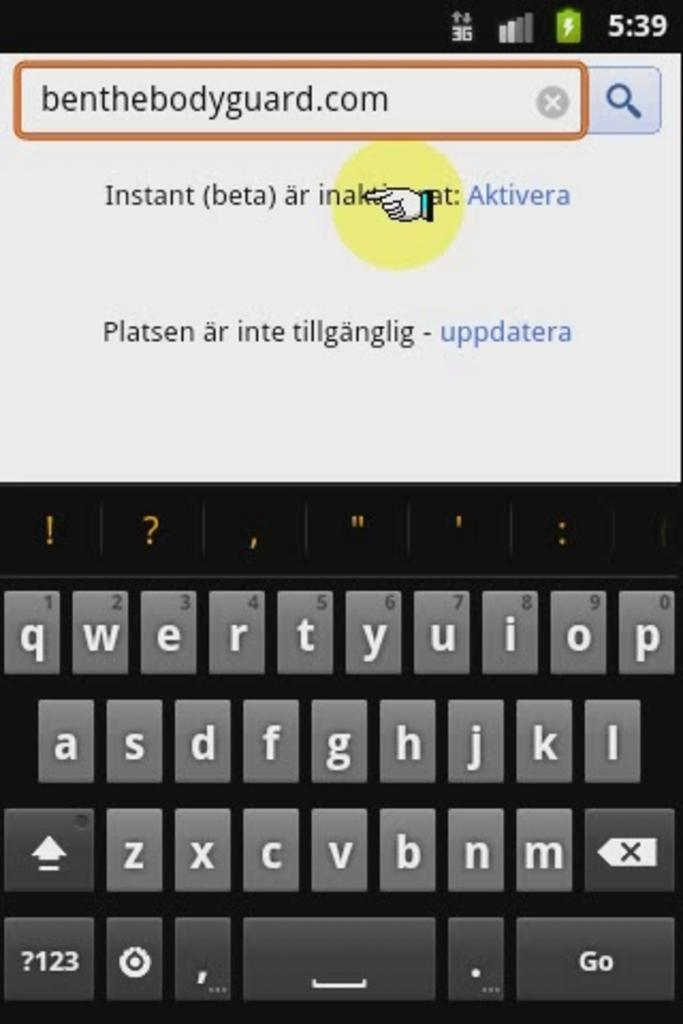Provide a one-sentence caption for the provided image. a picture of a keyboard with the word benthebodyguard.com at the top. 